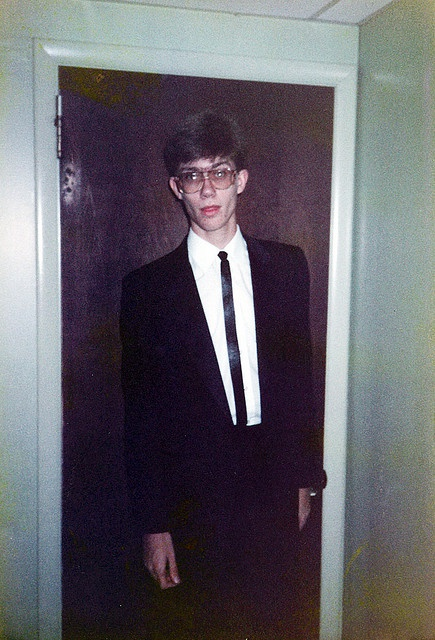Describe the objects in this image and their specific colors. I can see people in tan, black, white, purple, and maroon tones and tie in tan, black, gray, navy, and purple tones in this image. 